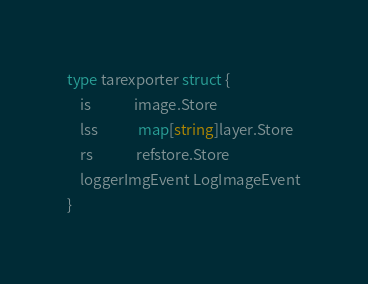<code> <loc_0><loc_0><loc_500><loc_500><_Go_>type tarexporter struct {
	is             image.Store
	lss            map[string]layer.Store
	rs             refstore.Store
	loggerImgEvent LogImageEvent
}
</code> 